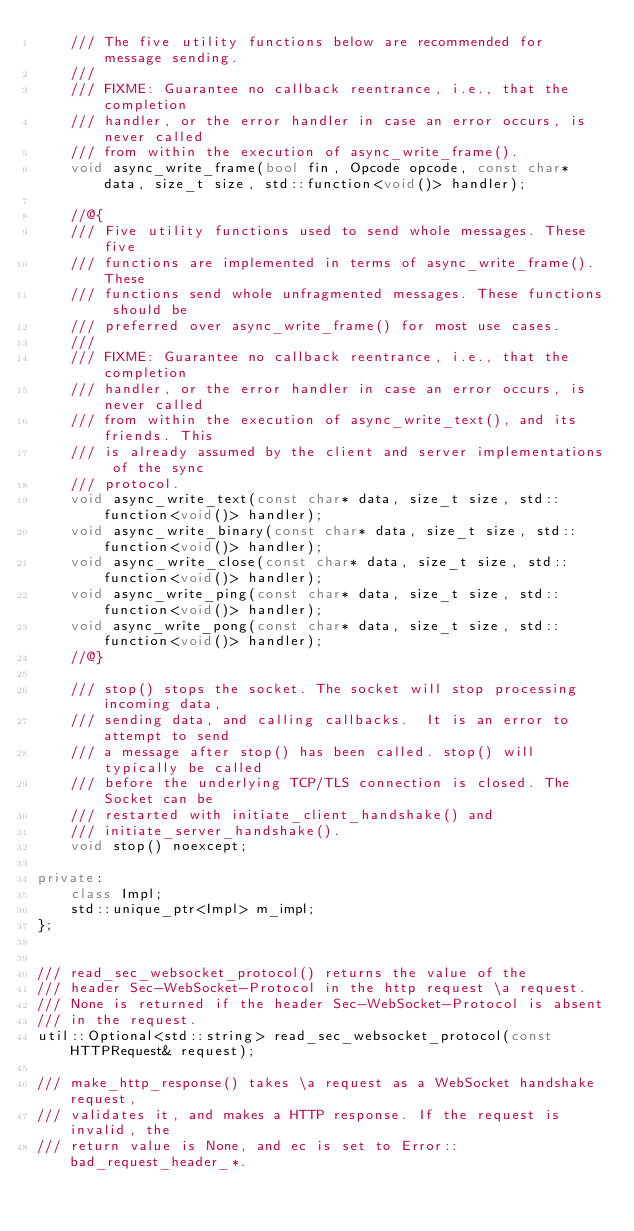<code> <loc_0><loc_0><loc_500><loc_500><_C++_>    /// The five utility functions below are recommended for message sending.
    ///
    /// FIXME: Guarantee no callback reentrance, i.e., that the completion
    /// handler, or the error handler in case an error occurs, is never called
    /// from within the execution of async_write_frame().
    void async_write_frame(bool fin, Opcode opcode, const char* data, size_t size, std::function<void()> handler);

    //@{
    /// Five utility functions used to send whole messages. These five
    /// functions are implemented in terms of async_write_frame(). These
    /// functions send whole unfragmented messages. These functions should be
    /// preferred over async_write_frame() for most use cases.
    ///
    /// FIXME: Guarantee no callback reentrance, i.e., that the completion
    /// handler, or the error handler in case an error occurs, is never called
    /// from within the execution of async_write_text(), and its friends. This
    /// is already assumed by the client and server implementations of the sync
    /// protocol.
    void async_write_text(const char* data, size_t size, std::function<void()> handler);
    void async_write_binary(const char* data, size_t size, std::function<void()> handler);
    void async_write_close(const char* data, size_t size, std::function<void()> handler);
    void async_write_ping(const char* data, size_t size, std::function<void()> handler);
    void async_write_pong(const char* data, size_t size, std::function<void()> handler);
    //@}

    /// stop() stops the socket. The socket will stop processing incoming data,
    /// sending data, and calling callbacks.  It is an error to attempt to send
    /// a message after stop() has been called. stop() will typically be called
    /// before the underlying TCP/TLS connection is closed. The Socket can be
    /// restarted with initiate_client_handshake() and
    /// initiate_server_handshake().
    void stop() noexcept;

private:
    class Impl;
    std::unique_ptr<Impl> m_impl;
};


/// read_sec_websocket_protocol() returns the value of the
/// header Sec-WebSocket-Protocol in the http request \a request.
/// None is returned if the header Sec-WebSocket-Protocol is absent
/// in the request.
util::Optional<std::string> read_sec_websocket_protocol(const HTTPRequest& request);

/// make_http_response() takes \a request as a WebSocket handshake request,
/// validates it, and makes a HTTP response. If the request is invalid, the
/// return value is None, and ec is set to Error::bad_request_header_*.</code> 